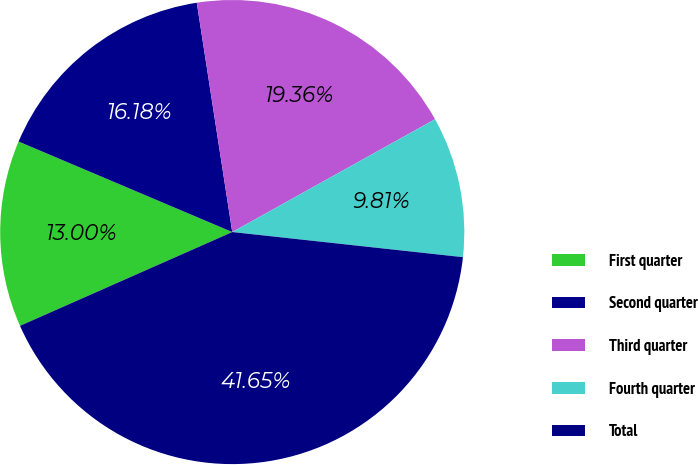Convert chart to OTSL. <chart><loc_0><loc_0><loc_500><loc_500><pie_chart><fcel>First quarter<fcel>Second quarter<fcel>Third quarter<fcel>Fourth quarter<fcel>Total<nl><fcel>13.0%<fcel>16.18%<fcel>19.36%<fcel>9.81%<fcel>41.65%<nl></chart> 